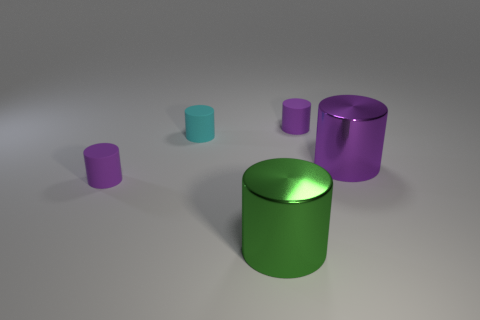Subtract all purple cylinders. How many were subtracted if there are1purple cylinders left? 2 Subtract all purple balls. How many purple cylinders are left? 3 Subtract all tiny cyan cylinders. How many cylinders are left? 4 Subtract all cyan cylinders. How many cylinders are left? 4 Subtract all red cylinders. Subtract all purple spheres. How many cylinders are left? 5 Add 4 small purple rubber cylinders. How many objects exist? 9 Subtract 0 yellow cubes. How many objects are left? 5 Subtract all large purple metal cylinders. Subtract all yellow shiny spheres. How many objects are left? 4 Add 4 cyan things. How many cyan things are left? 5 Add 2 small purple matte cylinders. How many small purple matte cylinders exist? 4 